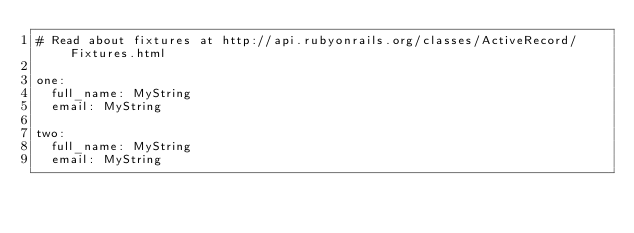<code> <loc_0><loc_0><loc_500><loc_500><_YAML_># Read about fixtures at http://api.rubyonrails.org/classes/ActiveRecord/Fixtures.html

one:
  full_name: MyString
  email: MyString

two:
  full_name: MyString
  email: MyString
</code> 